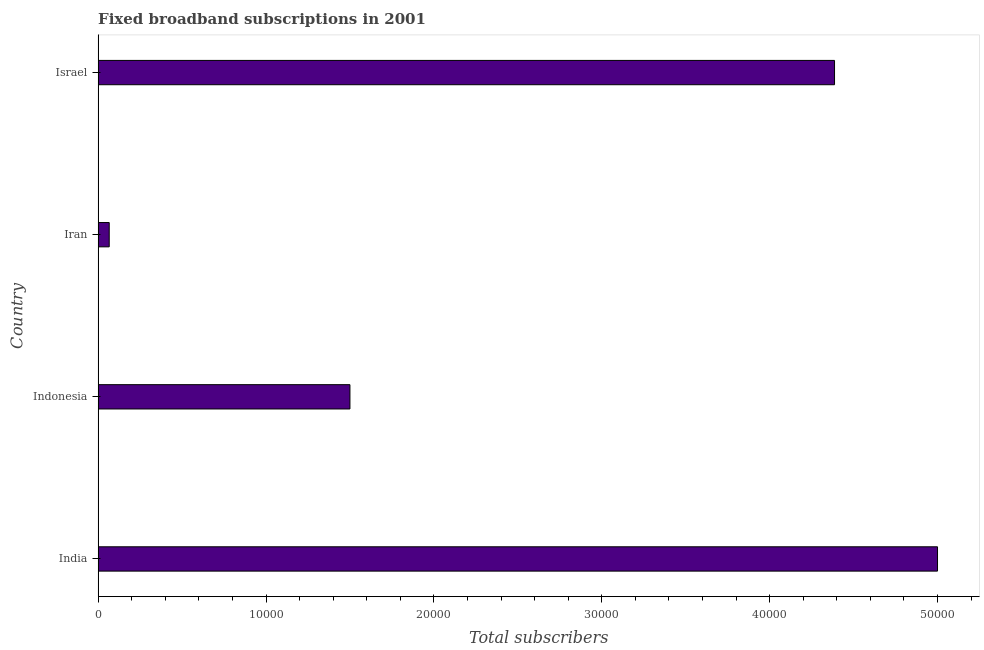What is the title of the graph?
Your answer should be very brief. Fixed broadband subscriptions in 2001. What is the label or title of the X-axis?
Provide a short and direct response. Total subscribers. What is the label or title of the Y-axis?
Keep it short and to the point. Country. What is the total number of fixed broadband subscriptions in India?
Give a very brief answer. 5.00e+04. Across all countries, what is the maximum total number of fixed broadband subscriptions?
Your response must be concise. 5.00e+04. Across all countries, what is the minimum total number of fixed broadband subscriptions?
Your response must be concise. 661. In which country was the total number of fixed broadband subscriptions minimum?
Provide a succinct answer. Iran. What is the sum of the total number of fixed broadband subscriptions?
Your answer should be very brief. 1.10e+05. What is the difference between the total number of fixed broadband subscriptions in India and Indonesia?
Your answer should be very brief. 3.50e+04. What is the average total number of fixed broadband subscriptions per country?
Offer a terse response. 2.74e+04. What is the median total number of fixed broadband subscriptions?
Your answer should be very brief. 2.94e+04. In how many countries, is the total number of fixed broadband subscriptions greater than 28000 ?
Your response must be concise. 2. What is the ratio of the total number of fixed broadband subscriptions in Indonesia to that in Iran?
Provide a short and direct response. 22.69. What is the difference between the highest and the second highest total number of fixed broadband subscriptions?
Give a very brief answer. 6135. Is the sum of the total number of fixed broadband subscriptions in India and Iran greater than the maximum total number of fixed broadband subscriptions across all countries?
Your response must be concise. Yes. What is the difference between the highest and the lowest total number of fixed broadband subscriptions?
Your response must be concise. 4.93e+04. In how many countries, is the total number of fixed broadband subscriptions greater than the average total number of fixed broadband subscriptions taken over all countries?
Your answer should be compact. 2. How many bars are there?
Keep it short and to the point. 4. Are all the bars in the graph horizontal?
Give a very brief answer. Yes. What is the Total subscribers in Indonesia?
Offer a terse response. 1.50e+04. What is the Total subscribers in Iran?
Give a very brief answer. 661. What is the Total subscribers in Israel?
Offer a very short reply. 4.39e+04. What is the difference between the Total subscribers in India and Indonesia?
Make the answer very short. 3.50e+04. What is the difference between the Total subscribers in India and Iran?
Provide a succinct answer. 4.93e+04. What is the difference between the Total subscribers in India and Israel?
Offer a terse response. 6135. What is the difference between the Total subscribers in Indonesia and Iran?
Offer a very short reply. 1.43e+04. What is the difference between the Total subscribers in Indonesia and Israel?
Your response must be concise. -2.89e+04. What is the difference between the Total subscribers in Iran and Israel?
Ensure brevity in your answer.  -4.32e+04. What is the ratio of the Total subscribers in India to that in Indonesia?
Ensure brevity in your answer.  3.33. What is the ratio of the Total subscribers in India to that in Iran?
Ensure brevity in your answer.  75.64. What is the ratio of the Total subscribers in India to that in Israel?
Your response must be concise. 1.14. What is the ratio of the Total subscribers in Indonesia to that in Iran?
Provide a short and direct response. 22.69. What is the ratio of the Total subscribers in Indonesia to that in Israel?
Offer a very short reply. 0.34. What is the ratio of the Total subscribers in Iran to that in Israel?
Offer a terse response. 0.01. 